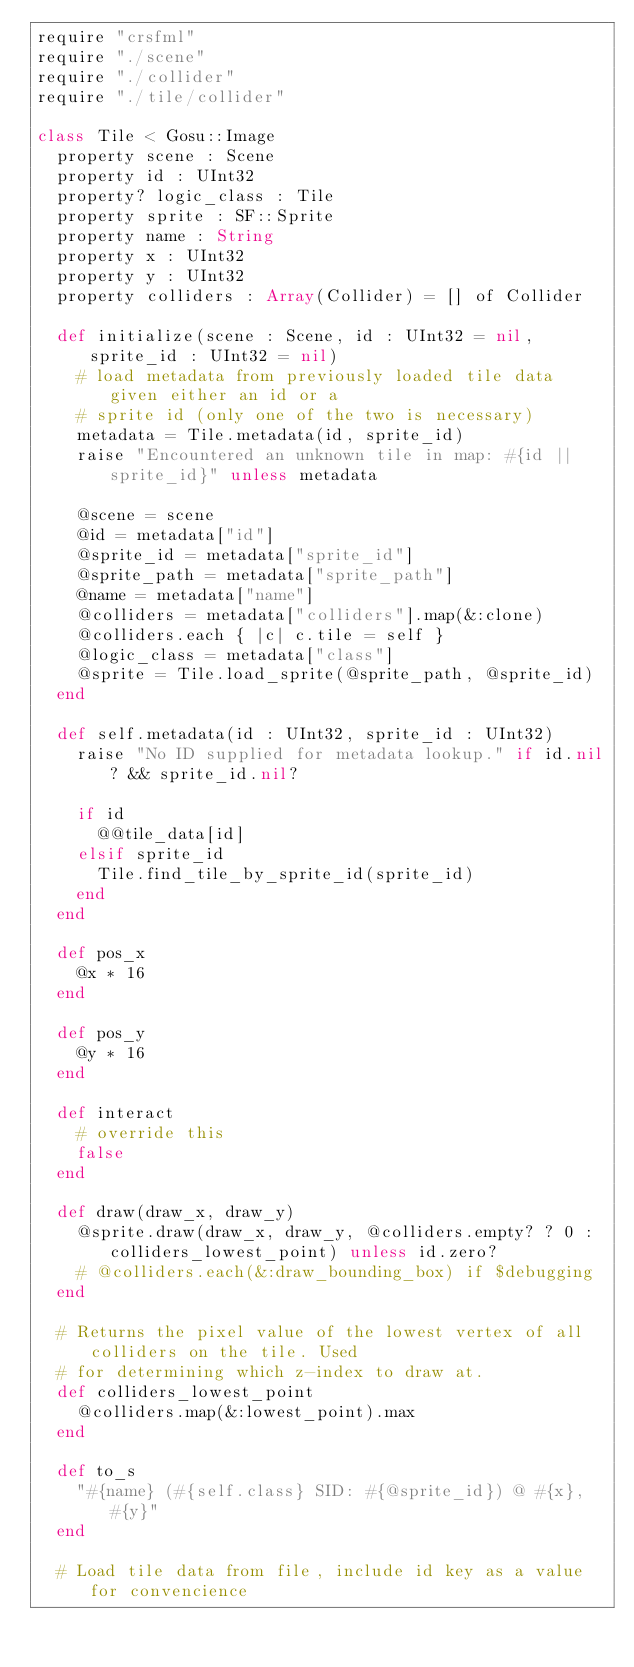<code> <loc_0><loc_0><loc_500><loc_500><_Crystal_>require "crsfml"
require "./scene"
require "./collider"
require "./tile/collider"

class Tile < Gosu::Image
  property scene : Scene
  property id : UInt32
  property? logic_class : Tile
  property sprite : SF::Sprite
  property name : String
  property x : UInt32
  property y : UInt32
  property colliders : Array(Collider) = [] of Collider

  def initialize(scene : Scene, id : UInt32 = nil, sprite_id : UInt32 = nil)
    # load metadata from previously loaded tile data given either an id or a
    # sprite id (only one of the two is necessary)
    metadata = Tile.metadata(id, sprite_id)
    raise "Encountered an unknown tile in map: #{id || sprite_id}" unless metadata

    @scene = scene
    @id = metadata["id"]
    @sprite_id = metadata["sprite_id"]
    @sprite_path = metadata["sprite_path"]
    @name = metadata["name"]
    @colliders = metadata["colliders"].map(&:clone)
    @colliders.each { |c| c.tile = self }
    @logic_class = metadata["class"]
    @sprite = Tile.load_sprite(@sprite_path, @sprite_id)
  end

  def self.metadata(id : UInt32, sprite_id : UInt32)
    raise "No ID supplied for metadata lookup." if id.nil? && sprite_id.nil?

    if id
      @@tile_data[id]
    elsif sprite_id
      Tile.find_tile_by_sprite_id(sprite_id)
    end
  end

  def pos_x
    @x * 16
  end

  def pos_y
    @y * 16
  end

  def interact
    # override this
    false
  end

  def draw(draw_x, draw_y)
    @sprite.draw(draw_x, draw_y, @colliders.empty? ? 0 : colliders_lowest_point) unless id.zero?
    # @colliders.each(&:draw_bounding_box) if $debugging
  end

  # Returns the pixel value of the lowest vertex of all colliders on the tile. Used
  # for determining which z-index to draw at.
  def colliders_lowest_point
    @colliders.map(&:lowest_point).max
  end

  def to_s
    "#{name} (#{self.class} SID: #{@sprite_id}) @ #{x}, #{y}"
  end

  # Load tile data from file, include id key as a value for convencience</code> 